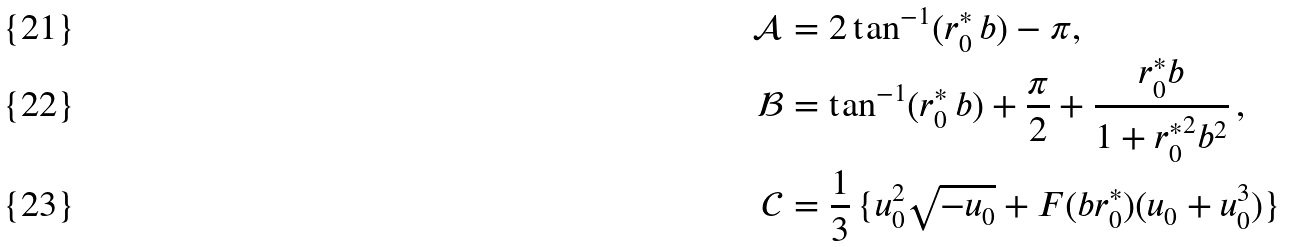<formula> <loc_0><loc_0><loc_500><loc_500>\mathcal { A } & = 2 \tan ^ { - 1 } ( r ^ { * } _ { 0 } \, b ) - \pi , \\ \mathcal { B } & = \tan ^ { - 1 } ( r ^ { * } _ { 0 } \, b ) + \frac { \pi } { 2 } + \frac { r ^ { * } _ { 0 } b } { 1 + { r ^ { * } _ { 0 } } ^ { 2 } b ^ { 2 } } \, , \\ \mathcal { C } & = \frac { 1 } { 3 } \, \{ u _ { 0 } ^ { 2 } \sqrt { - u _ { 0 } } + F ( b r ^ { * } _ { 0 } ) ( u _ { 0 } + u _ { 0 } ^ { 3 } ) \}</formula> 